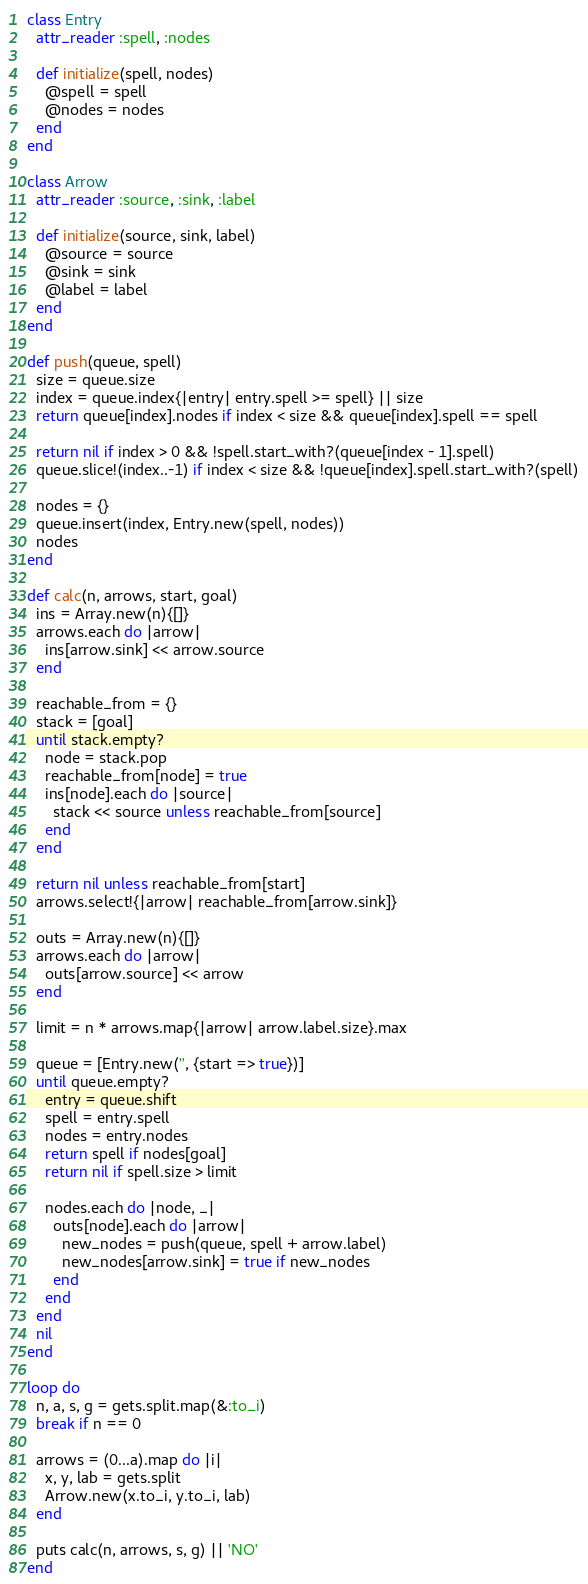<code> <loc_0><loc_0><loc_500><loc_500><_Ruby_>
class Entry
  attr_reader :spell, :nodes

  def initialize(spell, nodes)
    @spell = spell
    @nodes = nodes
  end
end
 
class Arrow
  attr_reader :source, :sink, :label

  def initialize(source, sink, label)
    @source = source
    @sink = sink
    @label = label
  end
end

def push(queue, spell)
  size = queue.size
  index = queue.index{|entry| entry.spell >= spell} || size
  return queue[index].nodes if index < size && queue[index].spell == spell

  return nil if index > 0 && !spell.start_with?(queue[index - 1].spell)
  queue.slice!(index..-1) if index < size && !queue[index].spell.start_with?(spell)

  nodes = {}
  queue.insert(index, Entry.new(spell, nodes))
  nodes
end

def calc(n, arrows, start, goal)
  ins = Array.new(n){[]}
  arrows.each do |arrow|
    ins[arrow.sink] << arrow.source
  end

  reachable_from = {}
  stack = [goal]
  until stack.empty?
    node = stack.pop
    reachable_from[node] = true
    ins[node].each do |source|
      stack << source unless reachable_from[source]
    end
  end

  return nil unless reachable_from[start]
  arrows.select!{|arrow| reachable_from[arrow.sink]}

  outs = Array.new(n){[]}
  arrows.each do |arrow|
    outs[arrow.source] << arrow
  end

  limit = n * arrows.map{|arrow| arrow.label.size}.max

  queue = [Entry.new('', {start => true})]
  until queue.empty?
    entry = queue.shift
    spell = entry.spell
    nodes = entry.nodes
    return spell if nodes[goal]
    return nil if spell.size > limit

    nodes.each do |node, _|
      outs[node].each do |arrow|
        new_nodes = push(queue, spell + arrow.label)
        new_nodes[arrow.sink] = true if new_nodes
      end
    end
  end
  nil
end

loop do
  n, a, s, g = gets.split.map(&:to_i)
  break if n == 0

  arrows = (0...a).map do |i|
    x, y, lab = gets.split
    Arrow.new(x.to_i, y.to_i, lab)
  end

  puts calc(n, arrows, s, g) || 'NO'
end</code> 